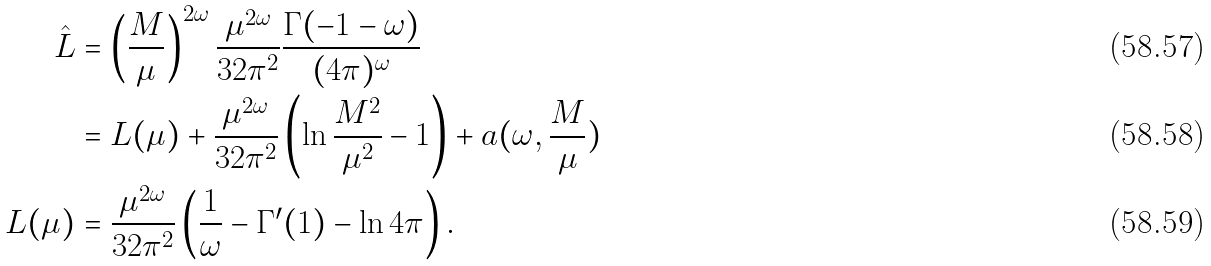Convert formula to latex. <formula><loc_0><loc_0><loc_500><loc_500>\hat { L } & = \left ( \frac { M } { \mu } \right ) ^ { 2 \omega } \frac { \mu ^ { 2 \omega } } { 3 2 \pi ^ { 2 } } \frac { \Gamma ( - 1 - \omega ) } { ( 4 \pi ) ^ { \omega } } \\ & = L ( \mu ) + \frac { \mu ^ { 2 \omega } } { 3 2 \pi ^ { 2 } } \left ( \ln \frac { M ^ { 2 } } { \mu ^ { 2 } } - 1 \right ) + a ( \omega , \frac { M } { \mu } ) \\ L ( \mu ) & = \frac { \mu ^ { 2 \omega } } { 3 2 \pi ^ { 2 } } \left ( \frac { 1 } { \omega } - \Gamma ^ { \prime } ( 1 ) - \ln 4 \pi \right ) .</formula> 